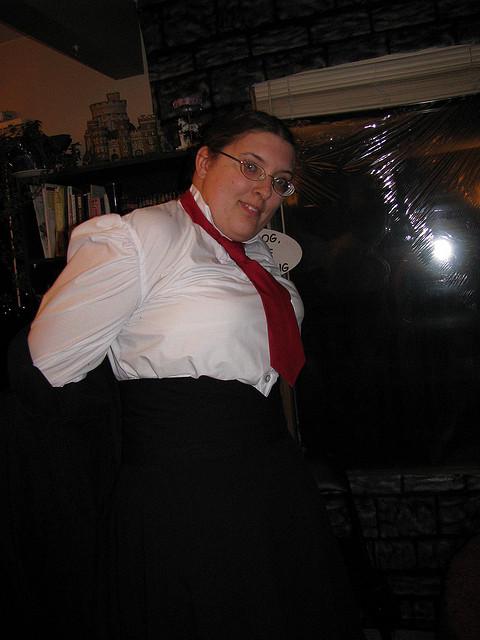Is the sun visible in this room?
Answer briefly. No. Is this woman in uniform?
Quick response, please. Yes. Does this lady have on a black tie?
Give a very brief answer. No. 